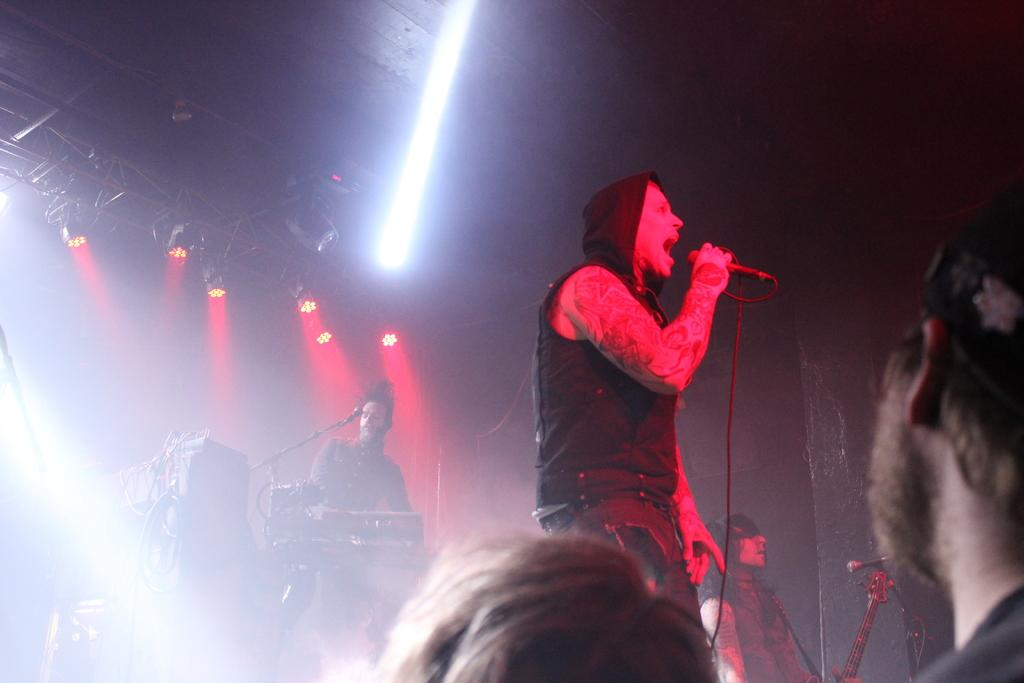How many people are in the image? There are people in the image, but the exact number is not specified. What is the man holding in the image? The man is holding a mic in the image. What is the man wearing in the image? The man is wearing a hoodie in the image. What can be seen in the background of the image? There are lights visible in the background of the image. Can you see any elbows in the image? The provided facts do not mention any elbows, so it is not possible to determine if any are visible in the image. 